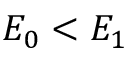Convert formula to latex. <formula><loc_0><loc_0><loc_500><loc_500>E _ { 0 } < E _ { 1 }</formula> 